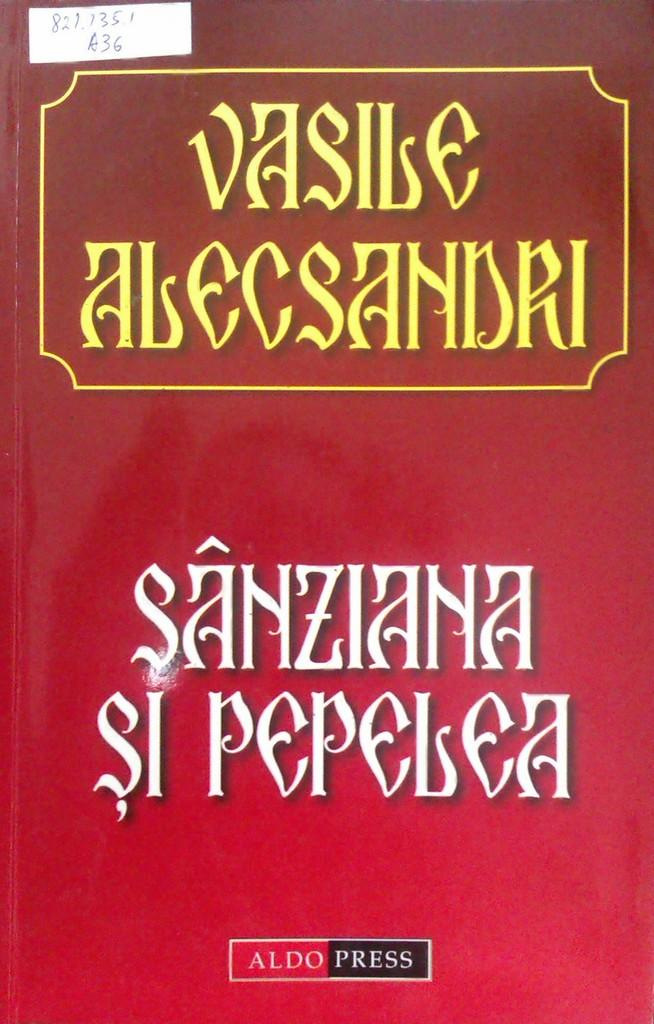<image>
Give a short and clear explanation of the subsequent image. A red paperbook from Aldo Press has a hand-written label in the top left corner. 